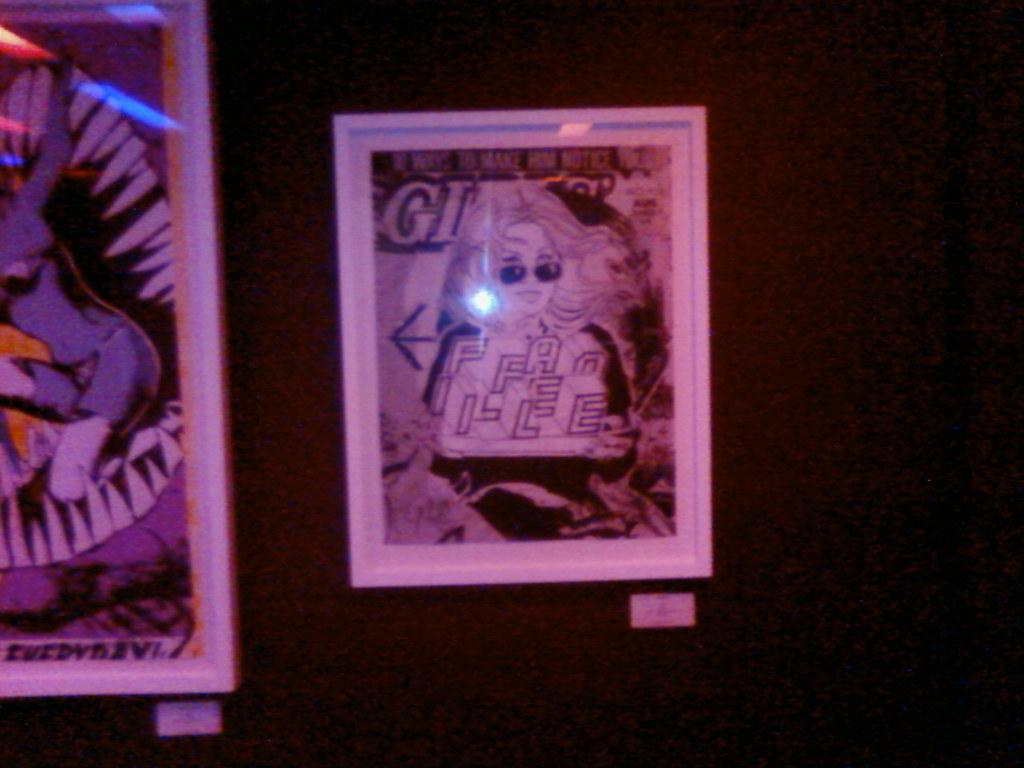Provide a one-sentence caption for the provided image. a framed paper that says 'gi' on it. 